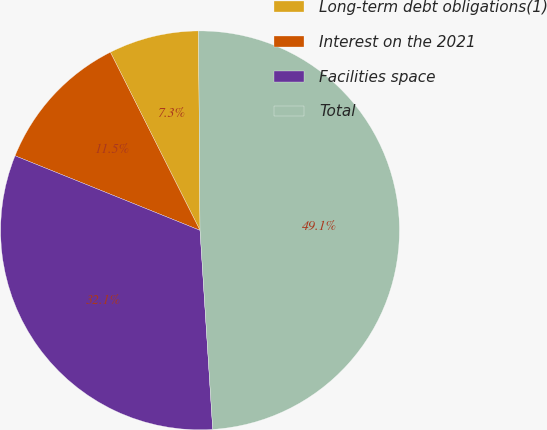<chart> <loc_0><loc_0><loc_500><loc_500><pie_chart><fcel>Long-term debt obligations(1)<fcel>Interest on the 2021<fcel>Facilities space<fcel>Total<nl><fcel>7.3%<fcel>11.48%<fcel>32.11%<fcel>49.1%<nl></chart> 